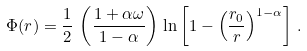Convert formula to latex. <formula><loc_0><loc_0><loc_500><loc_500>\Phi ( r ) = \frac { 1 } { 2 } \, \left ( \frac { 1 + \alpha \omega } { 1 - \alpha } \right ) \, \ln \left [ 1 - \left ( \frac { r _ { 0 } } { r } \right ) ^ { 1 - \alpha } \right ] \, .</formula> 